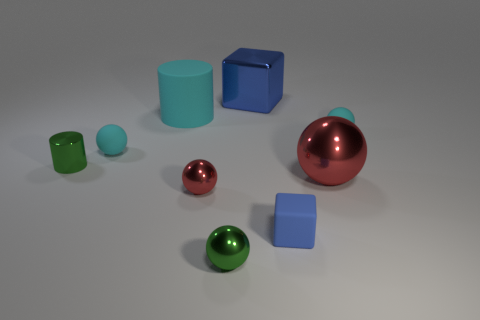What is the size of the shiny object that is the same shape as the blue matte object?
Make the answer very short. Large. Is the small block the same color as the big block?
Provide a succinct answer. Yes. Are there fewer tiny metal cylinders right of the green sphere than tiny gray cylinders?
Offer a terse response. No. Is the color of the block behind the large sphere the same as the small rubber block?
Keep it short and to the point. Yes. What number of metal things are either red spheres or big blue blocks?
Offer a terse response. 3. What is the color of the block that is made of the same material as the small cylinder?
Keep it short and to the point. Blue. How many cylinders are either big cyan things or metal objects?
Offer a terse response. 2. How many things are tiny shiny spheres or large rubber cylinders behind the small green metallic ball?
Keep it short and to the point. 3. Is there a tiny brown rubber cube?
Provide a succinct answer. No. How many small metal things are the same color as the big metallic block?
Your answer should be compact. 0. 